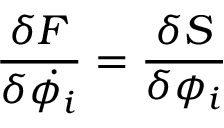<formula> <loc_0><loc_0><loc_500><loc_500>{ \frac { \delta F } { \delta \dot { \phi _ { i } } } } = { \frac { \delta S } { \delta \phi _ { i } } }</formula> 